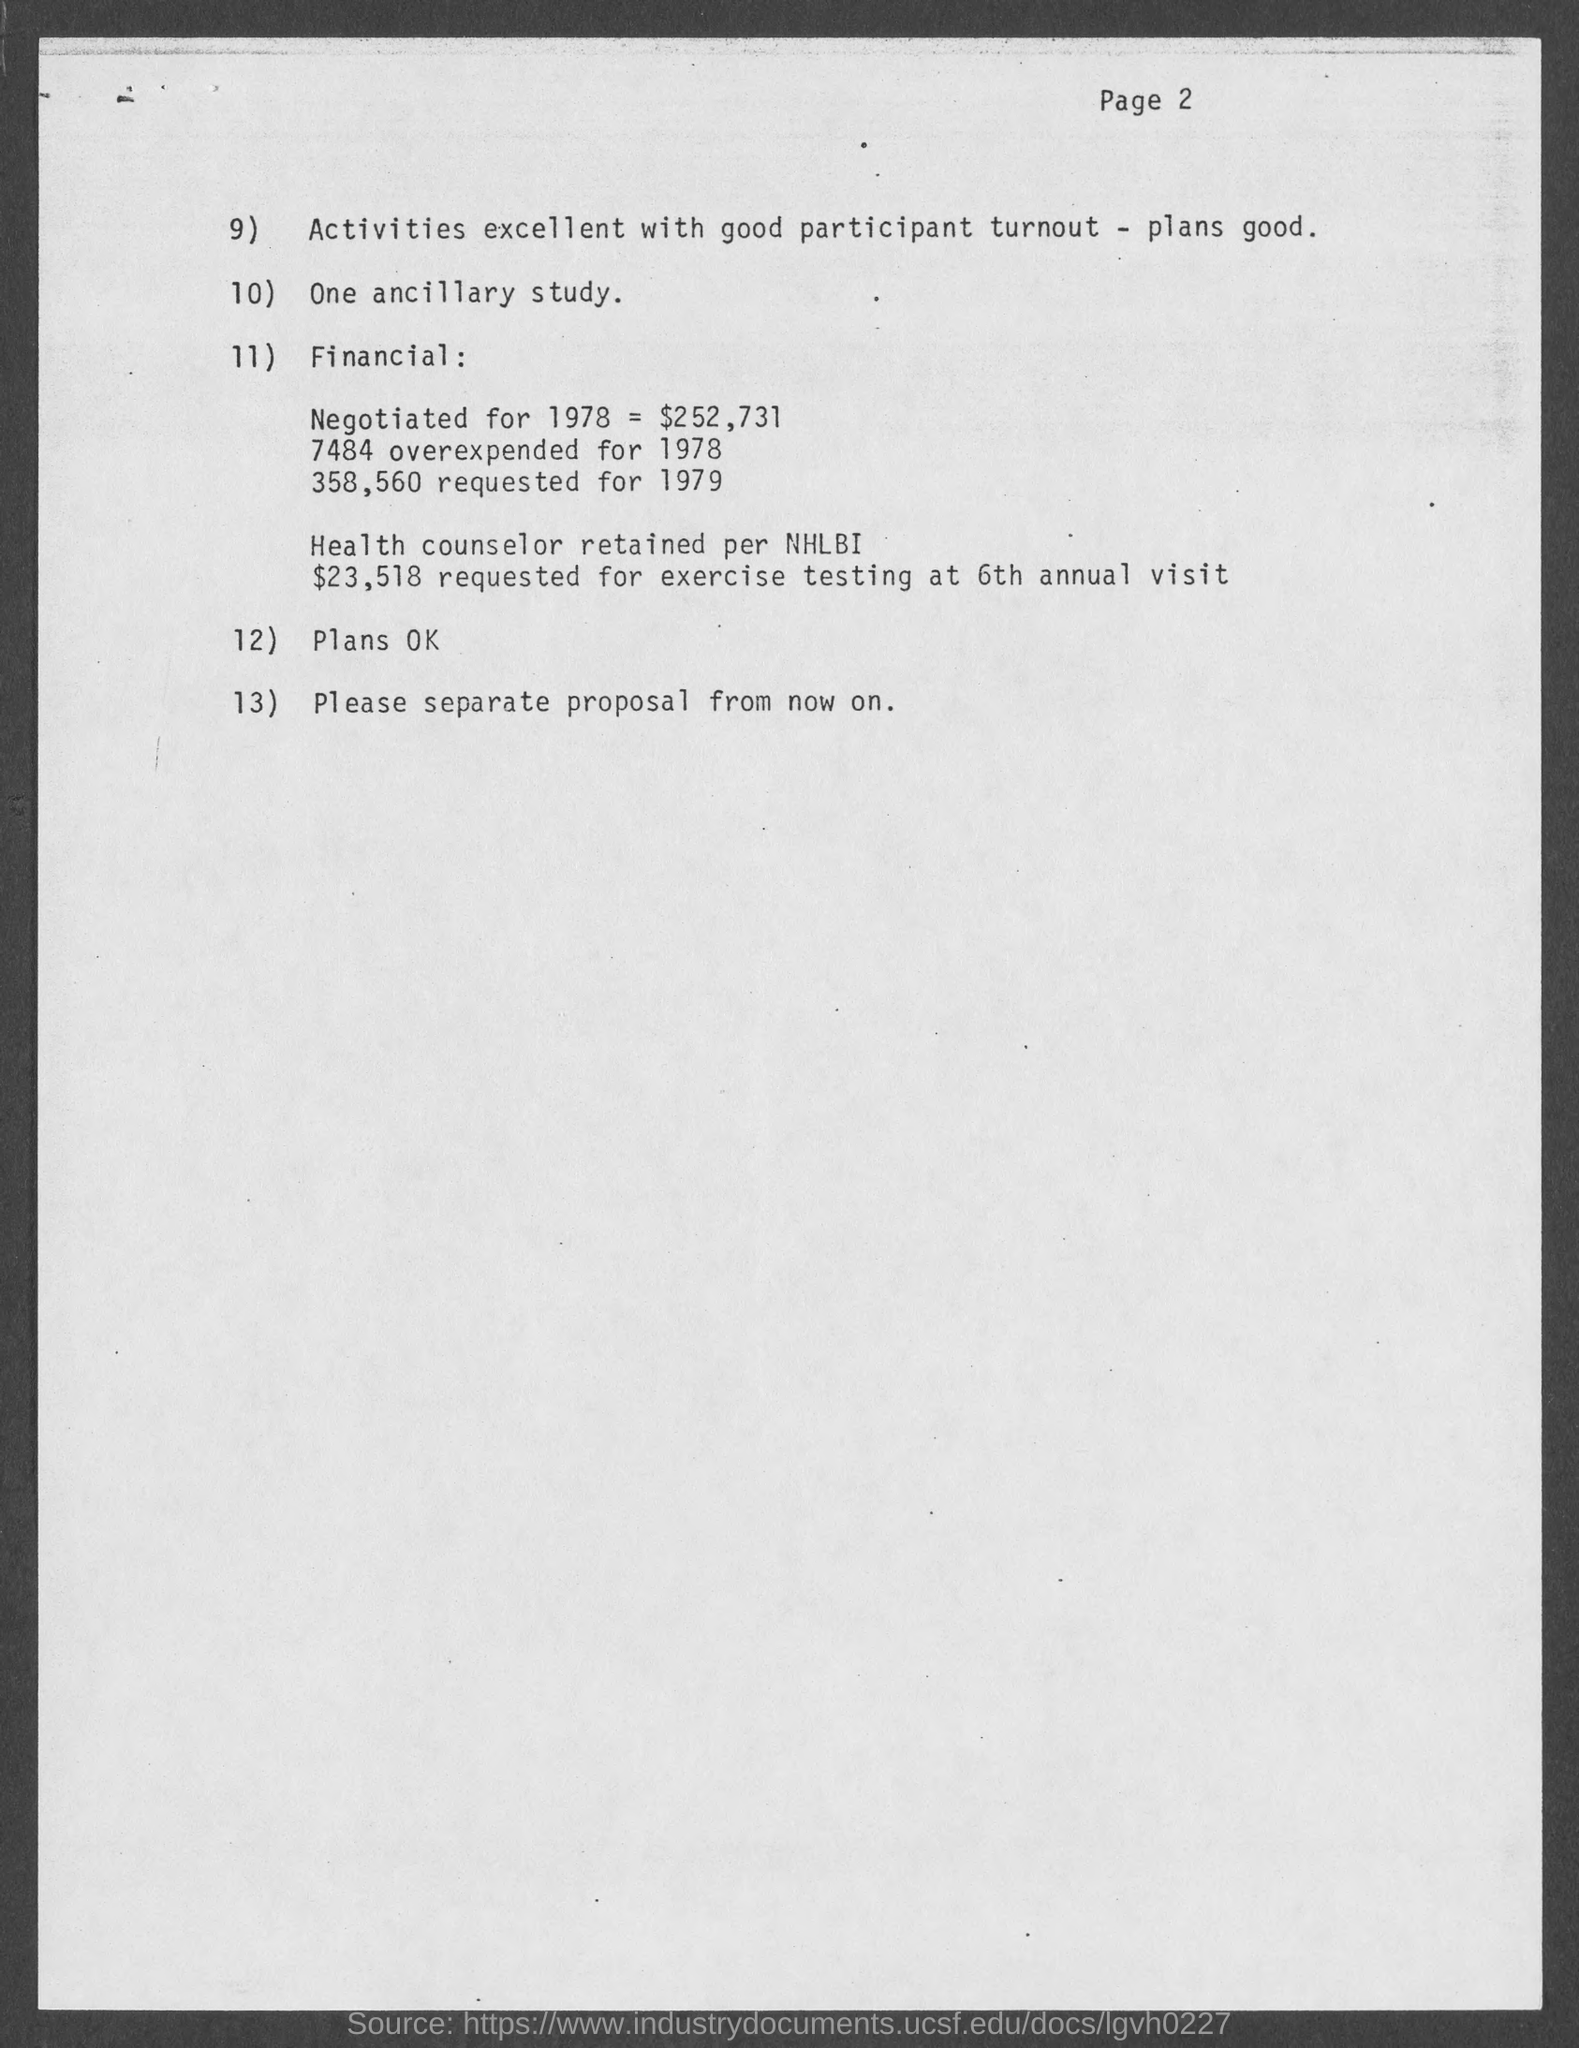Mention a couple of crucial points in this snapshot. The page number at the top of the page is two. 